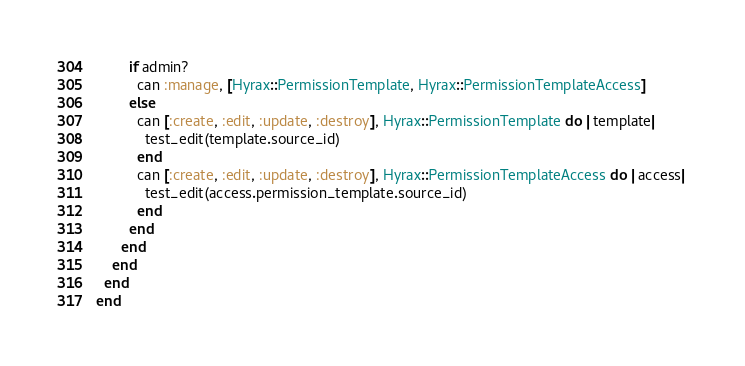Convert code to text. <code><loc_0><loc_0><loc_500><loc_500><_Ruby_>        if admin?
          can :manage, [Hyrax::PermissionTemplate, Hyrax::PermissionTemplateAccess]
        else
          can [:create, :edit, :update, :destroy], Hyrax::PermissionTemplate do |template|
            test_edit(template.source_id)
          end
          can [:create, :edit, :update, :destroy], Hyrax::PermissionTemplateAccess do |access|
            test_edit(access.permission_template.source_id)
          end
        end
      end
    end
  end
end
</code> 